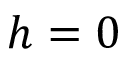Convert formula to latex. <formula><loc_0><loc_0><loc_500><loc_500>h = 0</formula> 